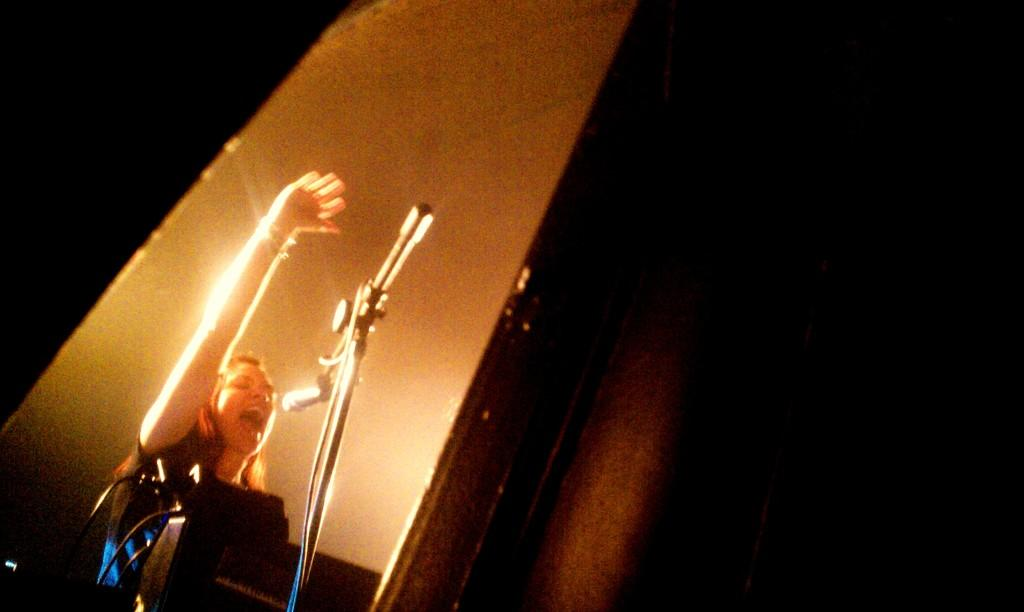What is the main subject of the image? There is a person in the image. What is the person doing in the image? The person is playing a musical instrument. What object is in front of the person? There is a mic in front of the person. What type of cracker is being used as a drumstick in the image? There is no cracker or drumstick present in the image; the person is playing a musical instrument with their hands or a traditional instrument accessory. 